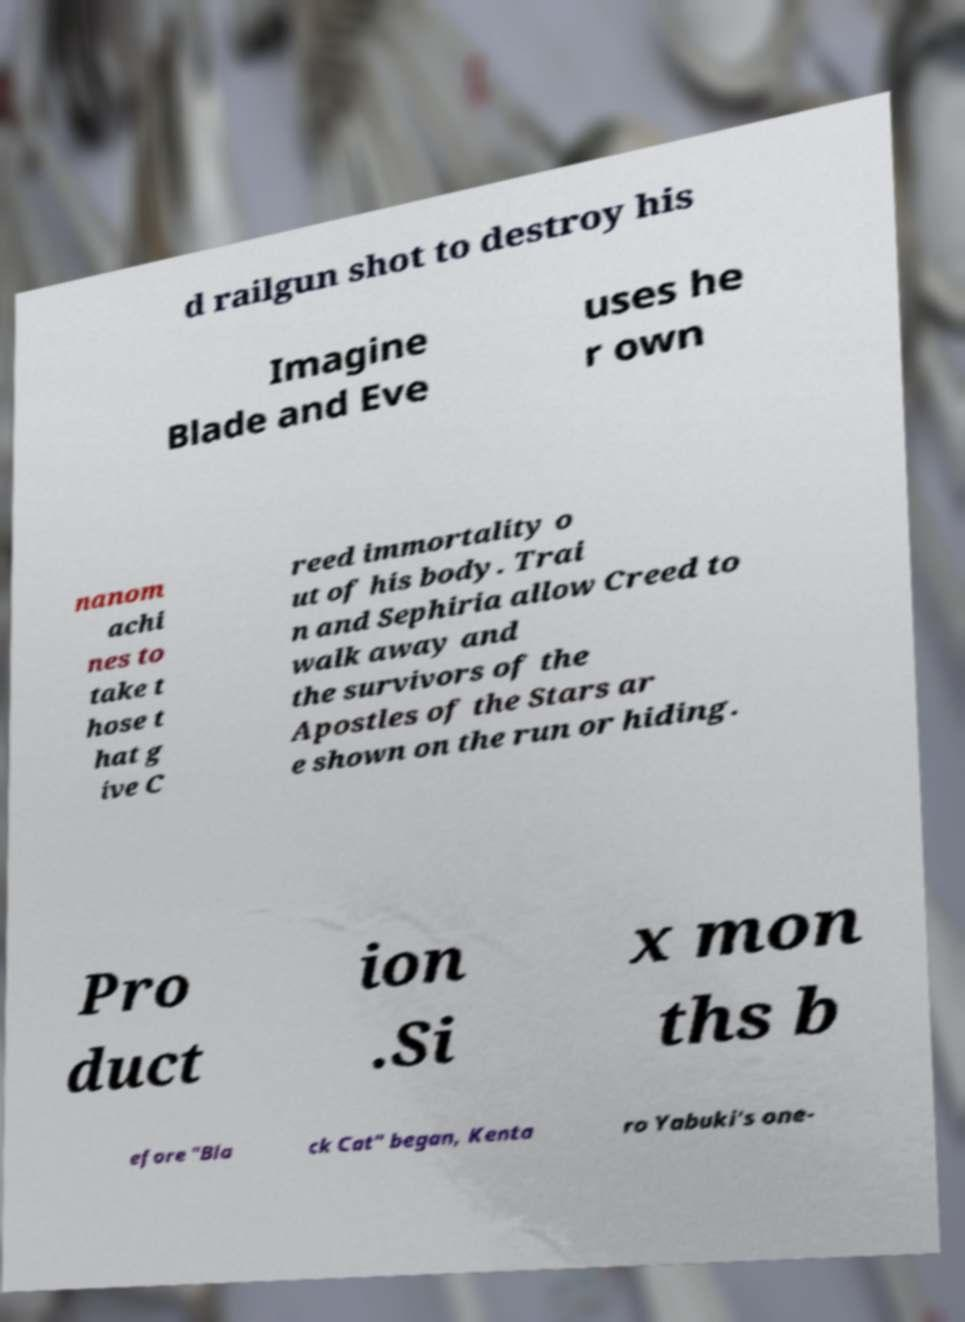Please read and relay the text visible in this image. What does it say? d railgun shot to destroy his Imagine Blade and Eve uses he r own nanom achi nes to take t hose t hat g ive C reed immortality o ut of his body. Trai n and Sephiria allow Creed to walk away and the survivors of the Apostles of the Stars ar e shown on the run or hiding. Pro duct ion .Si x mon ths b efore "Bla ck Cat" began, Kenta ro Yabuki's one- 